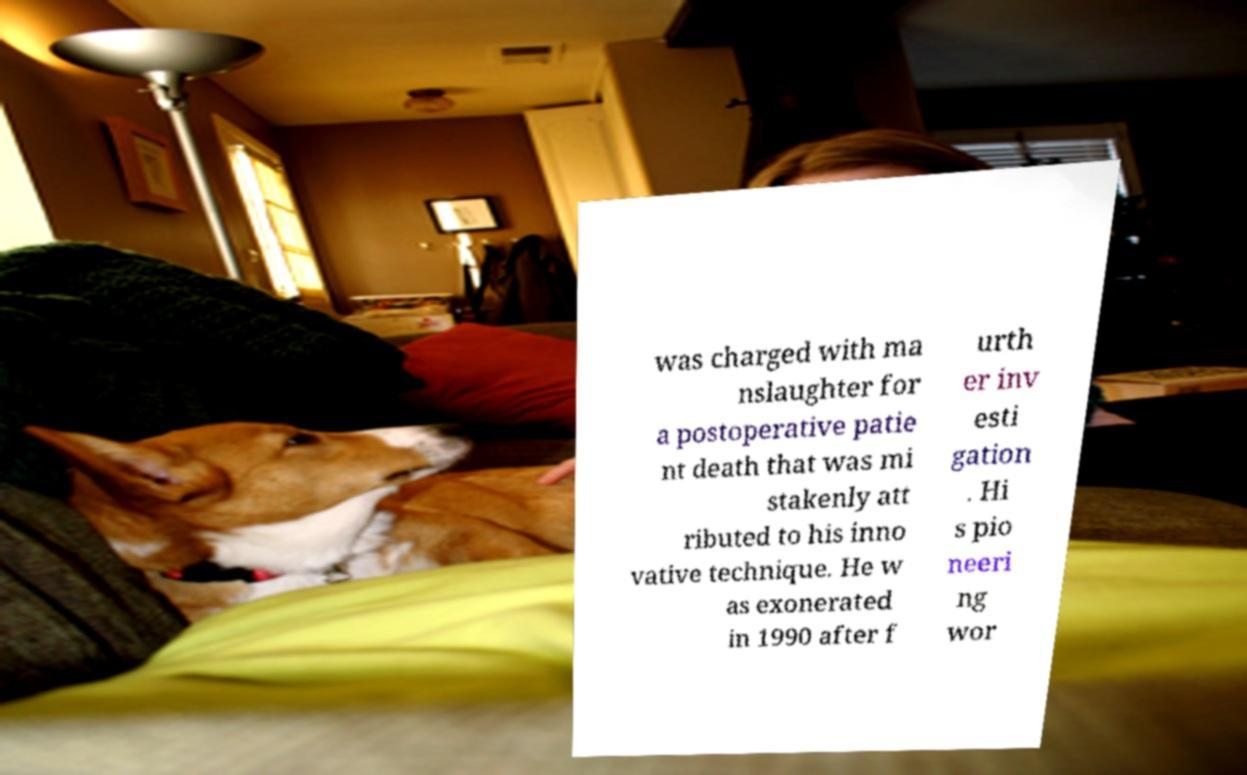Can you read and provide the text displayed in the image?This photo seems to have some interesting text. Can you extract and type it out for me? was charged with ma nslaughter for a postoperative patie nt death that was mi stakenly att ributed to his inno vative technique. He w as exonerated in 1990 after f urth er inv esti gation . Hi s pio neeri ng wor 